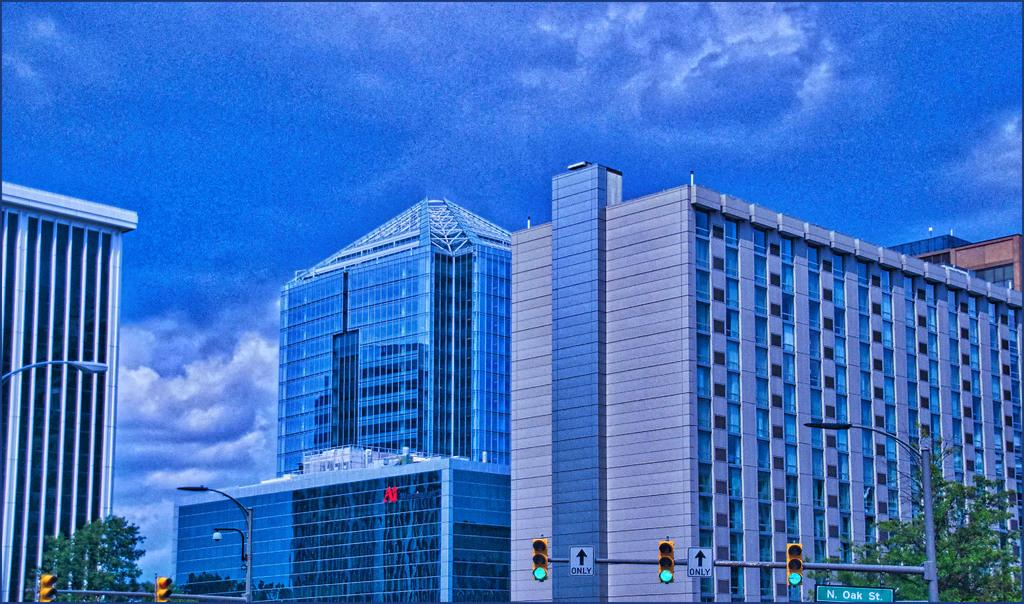What type of buildings can be seen in the image? There are glass buildings in the image. What infrastructure is present to regulate traffic in the image? There are traffic signals in the image. What structures are supporting wires or other elements in the image? There are poles in the image. What is the purpose of the board in the image? The purpose of the board in the image is not specified, but it could be used for advertising, information, or displaying messages. What type of vegetation is present in the image? There are trees in the image. What is the color of the sky in the image? The sky is blue and white in color. What type of breakfast is being served in the image? There is no breakfast present in the image; it features glass buildings, traffic signals, poles, a board, trees, and a blue and white sky. Is there a bed visible in the image? No, there is no bed present in the image. 